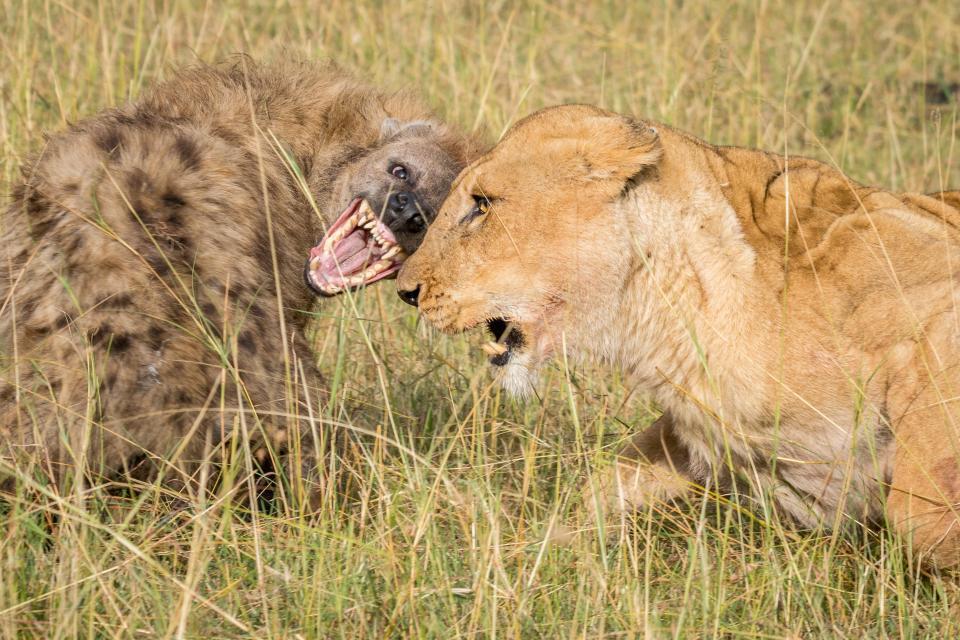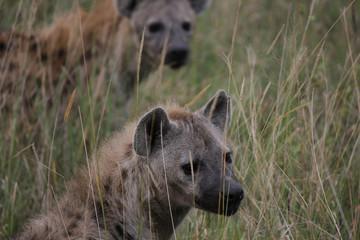The first image is the image on the left, the second image is the image on the right. Given the left and right images, does the statement "There are two hyenas in one of the images, and a lion near one or more hyenas in the other." hold true? Answer yes or no. Yes. The first image is the image on the left, the second image is the image on the right. Examine the images to the left and right. Is the description "An image shows an open-mouthed lion next to at least one hyena." accurate? Answer yes or no. Yes. 